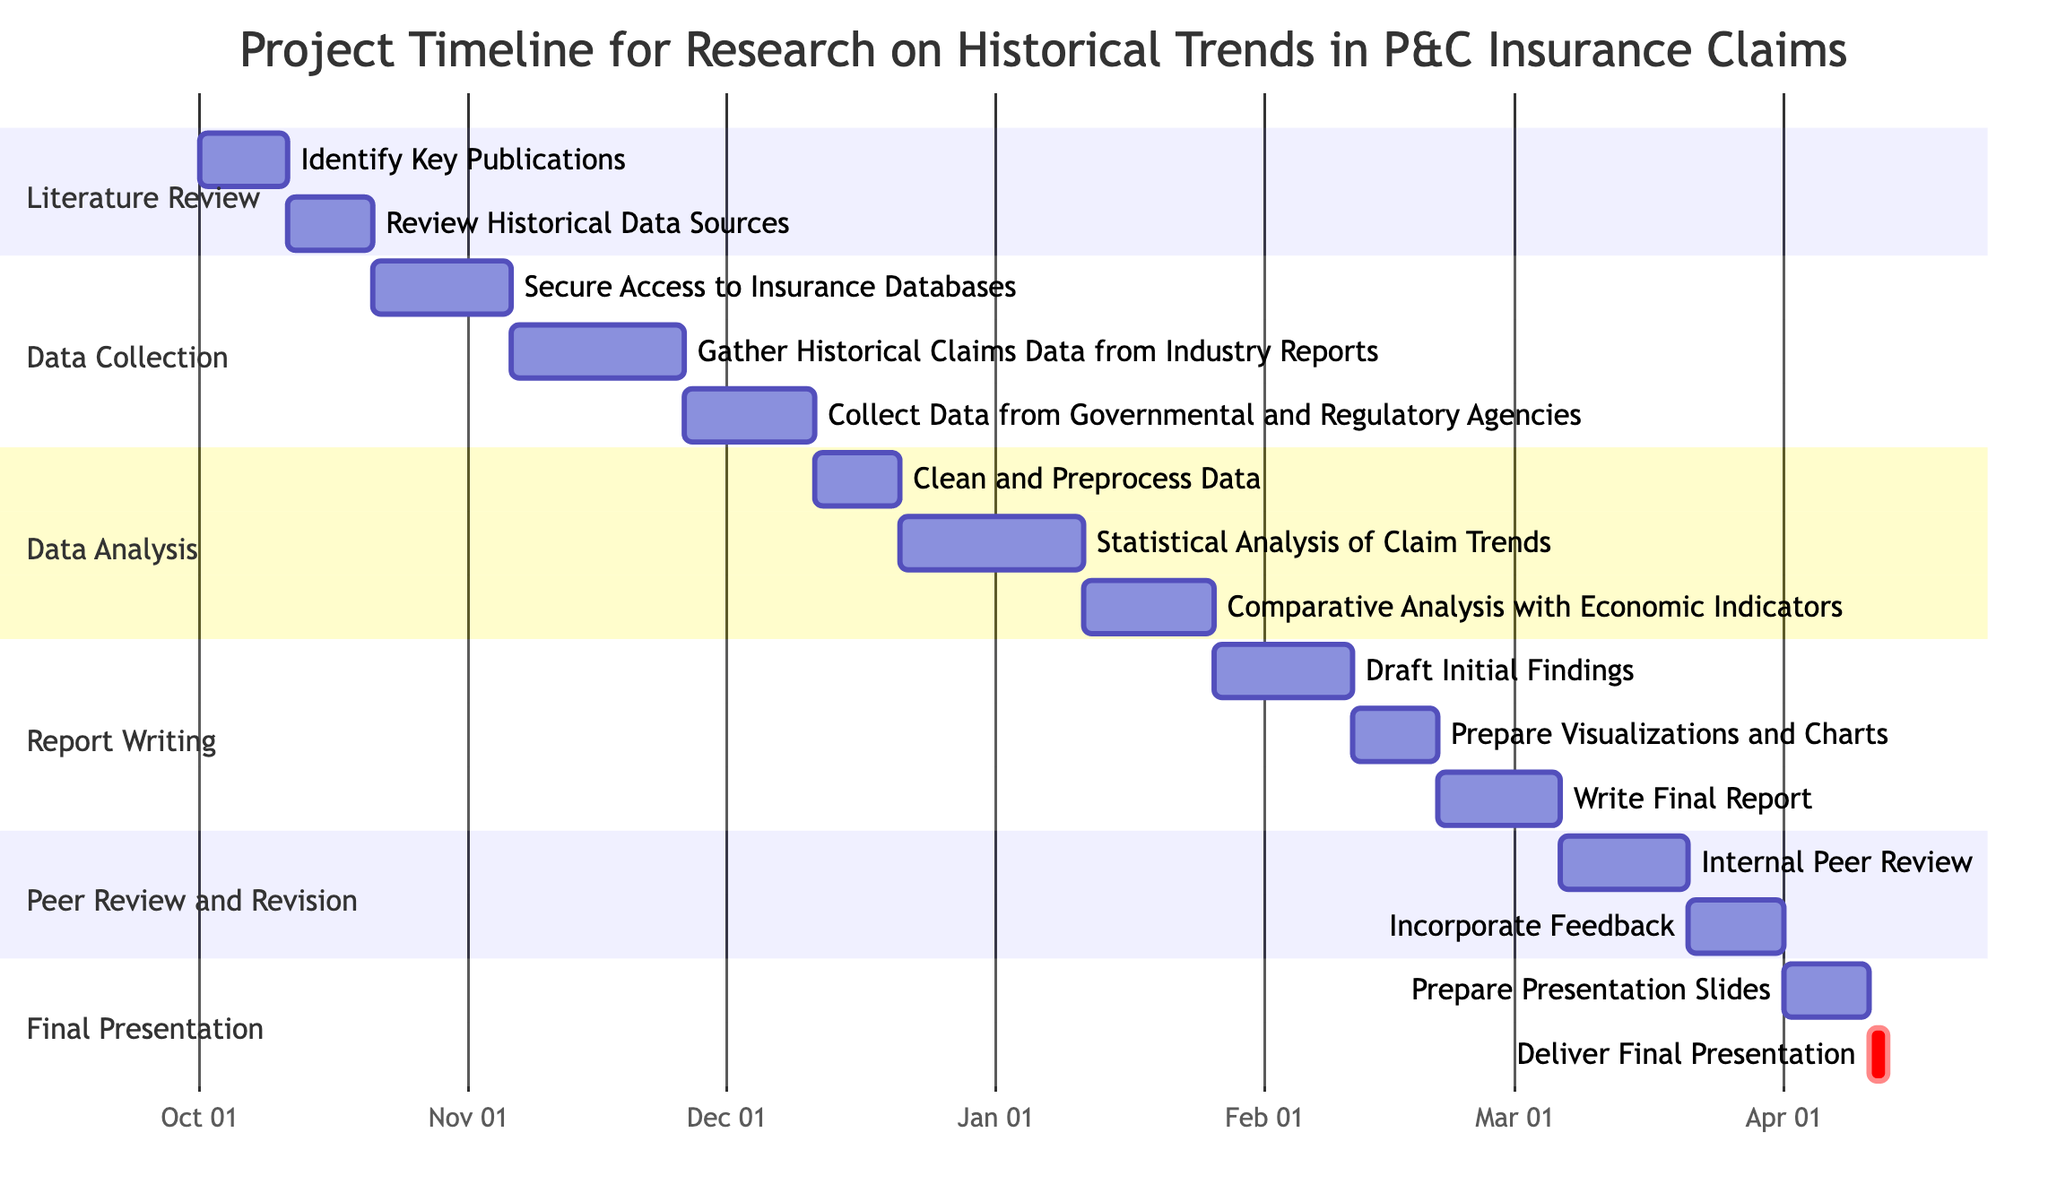What is the start date of the "Data Analysis" phase? The "Data Analysis" phase starts with the task "Clean and Preprocess Data," which has a start date of December 11, 2023.
Answer: December 11, 2023 How many tasks are included in the "Report Writing" phase? The "Report Writing" phase contains three tasks: "Draft Initial Findings," "Prepare Visualizations and Charts," and "Write Final Report." Therefore, there are three tasks in total.
Answer: 3 Which task follows "Statistical Analysis of Claim Trends"? The task that follows "Statistical Analysis of Claim Trends" is "Comparative Analysis with Economic Indicators," which starts on January 11, 2024.
Answer: Comparative Analysis with Economic Indicators What is the total duration of the "Data Collection" phase? The phase starts on October 21, 2023, and ends on December 10, 2023. To calculate the total duration: October 21 to November 5 is 16 days, and November 6 to December 10 adds another 20+15 days (35 days). In total, that's 51 days.
Answer: 51 days During which dates does the "Finalize Presentation" task occur? The "Finalize Presentation" task consists of two tasks: "Prepare Presentation Slides," which runs from April 1 to April 10, 2024, and "Deliver Final Presentation," which occurs on April 11 and 12, 2024. Thus, the task spans from April 1 through April 12, 2024.
Answer: April 1 - April 12, 2024 What is the last task in the project timeline? The last task in the project timeline is "Deliver Final Presentation," which runs from April 11 to April 12, 2024.
Answer: Deliver Final Presentation Which phase includes a task for incorporating feedback? The phase that includes the task "Incorporate Feedback" is the "Peer Review and Revision" phase.
Answer: Peer Review and Revision How long does the "Clean and Preprocess Data" task take? The "Clean and Preprocess Data" task starts on December 11 and ends on December 20, 2023. Thus, it takes 10 days.
Answer: 10 days 